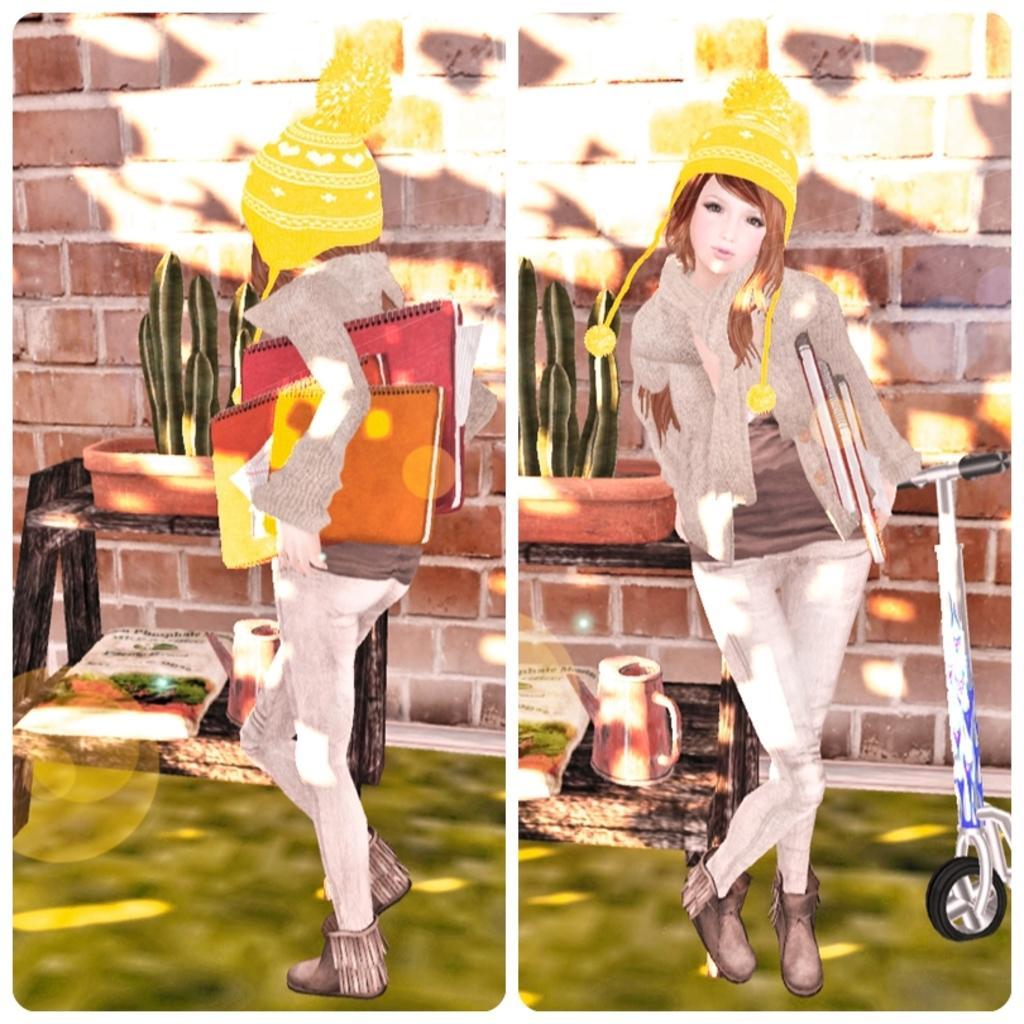Describe this image in one or two sentences. In the image there is a collage of two depictions. 